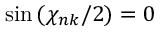Convert formula to latex. <formula><loc_0><loc_0><loc_500><loc_500>\sin { ( \chi _ { n k } / 2 ) } = 0</formula> 